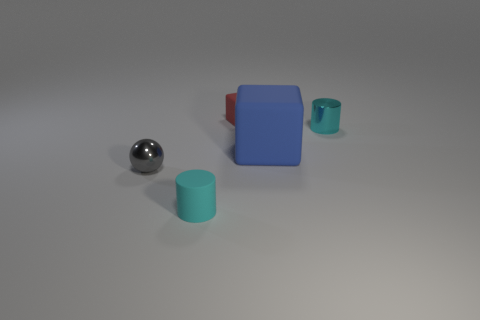Add 4 metallic balls. How many objects exist? 9 Subtract 1 spheres. How many spheres are left? 0 Subtract all blue cubes. How many cubes are left? 1 Subtract all cylinders. How many objects are left? 3 Subtract all green cubes. Subtract all red cylinders. How many cubes are left? 2 Subtract all brown spheres. How many red cubes are left? 1 Subtract all metallic things. Subtract all tiny blocks. How many objects are left? 2 Add 1 small cyan matte things. How many small cyan matte things are left? 2 Add 4 large matte things. How many large matte things exist? 5 Subtract 1 red blocks. How many objects are left? 4 